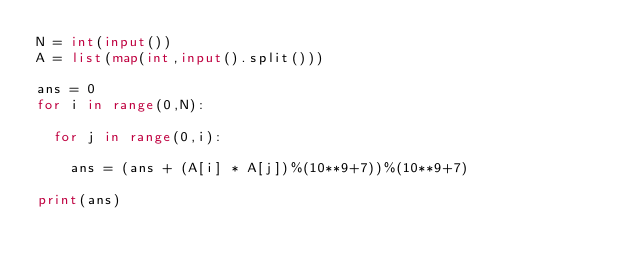Convert code to text. <code><loc_0><loc_0><loc_500><loc_500><_Python_>N = int(input())
A = list(map(int,input().split()))
 
ans = 0
for i in range(0,N):
  
  for j in range(0,i):
    
    ans = (ans + (A[i] * A[j])%(10**9+7))%(10**9+7)
 
print(ans)</code> 